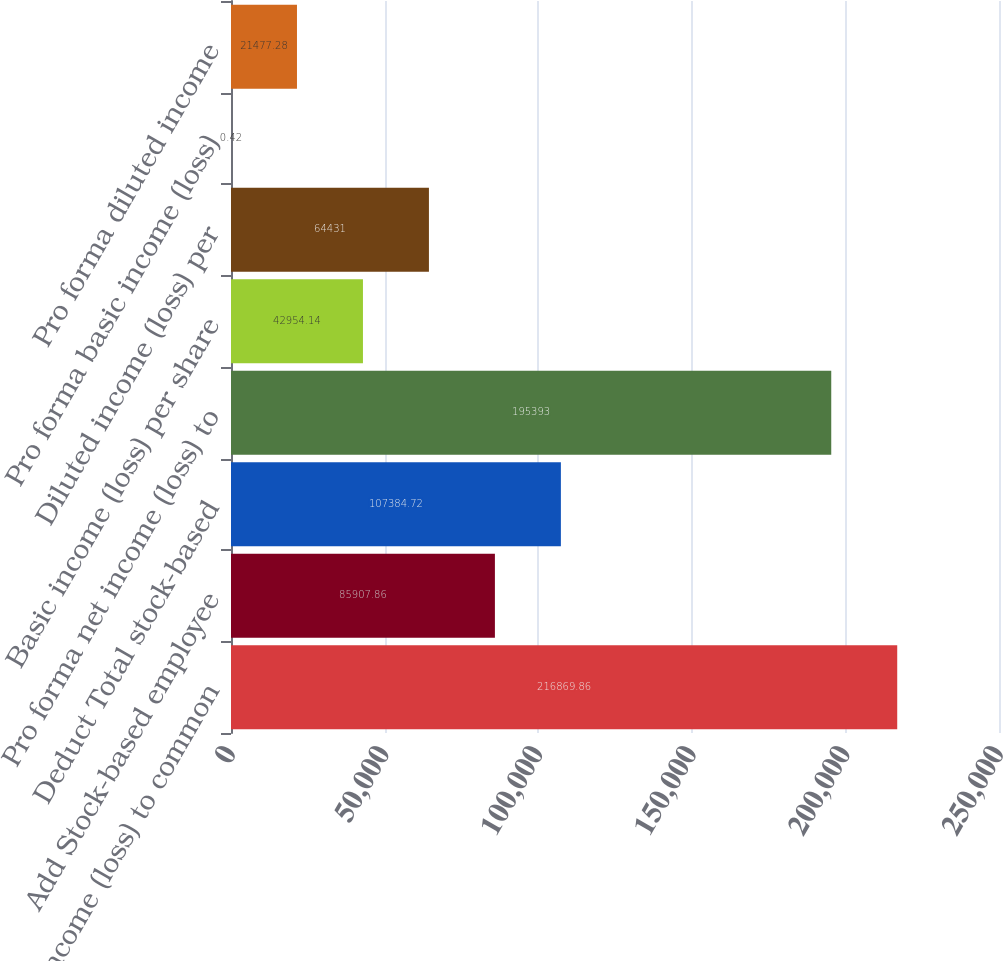<chart> <loc_0><loc_0><loc_500><loc_500><bar_chart><fcel>Net income (loss) to common<fcel>Add Stock-based employee<fcel>Deduct Total stock-based<fcel>Pro forma net income (loss) to<fcel>Basic income (loss) per share<fcel>Diluted income (loss) per<fcel>Pro forma basic income (loss)<fcel>Pro forma diluted income<nl><fcel>216870<fcel>85907.9<fcel>107385<fcel>195393<fcel>42954.1<fcel>64431<fcel>0.42<fcel>21477.3<nl></chart> 